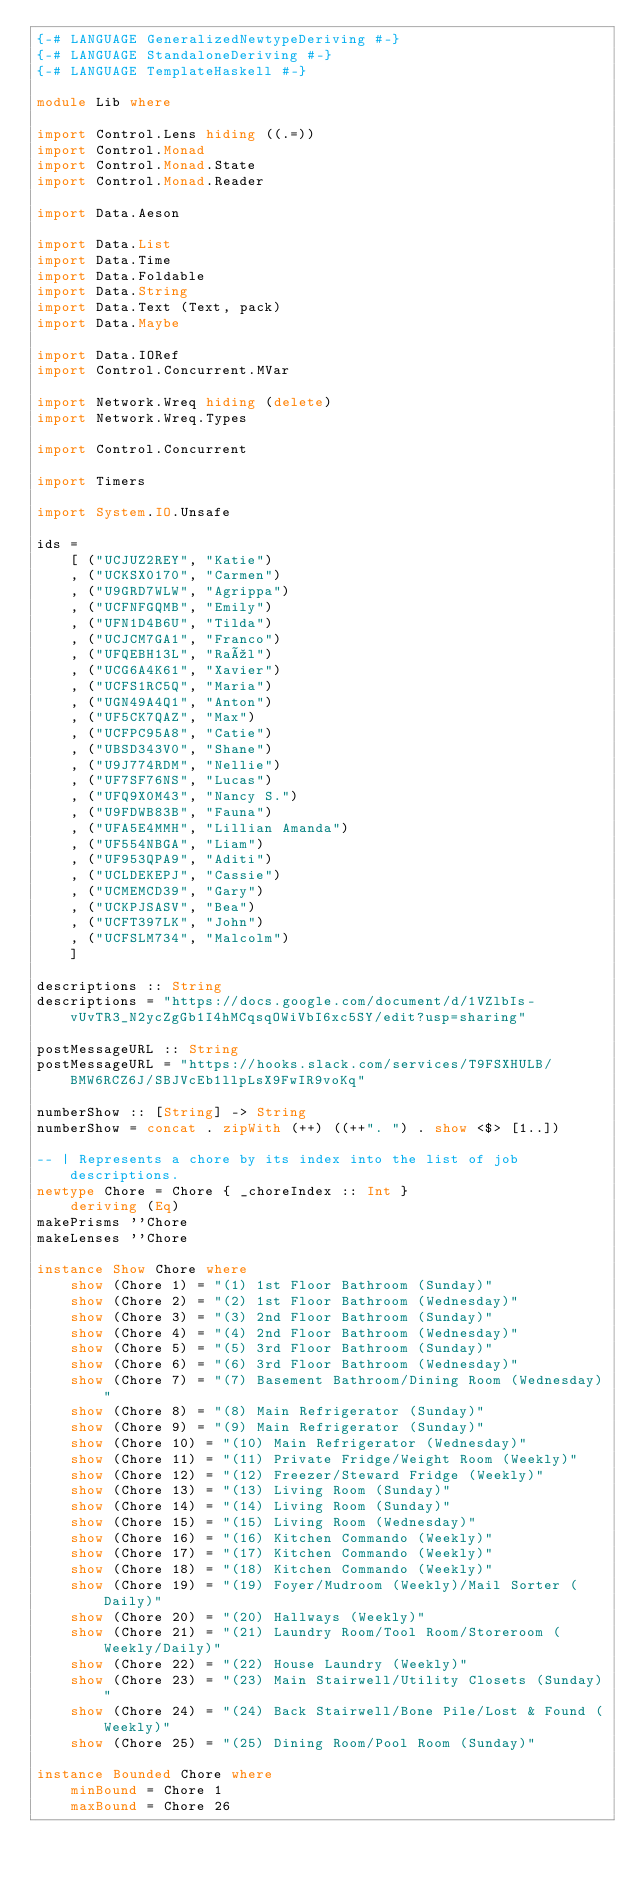<code> <loc_0><loc_0><loc_500><loc_500><_Haskell_>{-# LANGUAGE GeneralizedNewtypeDeriving #-}
{-# LANGUAGE StandaloneDeriving #-}
{-# LANGUAGE TemplateHaskell #-}

module Lib where

import Control.Lens hiding ((.=))
import Control.Monad
import Control.Monad.State
import Control.Monad.Reader

import Data.Aeson

import Data.List
import Data.Time
import Data.Foldable
import Data.String
import Data.Text (Text, pack)
import Data.Maybe

import Data.IORef
import Control.Concurrent.MVar

import Network.Wreq hiding (delete)
import Network.Wreq.Types

import Control.Concurrent

import Timers

import System.IO.Unsafe

ids =
    [ ("UCJUZ2REY", "Katie")
    , ("UCKSX0170", "Carmen")
    , ("U9GRD7WLW", "Agrippa")
    , ("UCFNFGQMB", "Emily")
    , ("UFN1D4B6U", "Tilda")
    , ("UCJCM7GA1", "Franco")
    , ("UFQEBH13L", "Raúl")
    , ("UCG6A4K61", "Xavier")
    , ("UCFS1RC5Q", "Maria")
    , ("UGN49A4Q1", "Anton")
    , ("UF5CK7QAZ", "Max")
    , ("UCFPC95A8", "Catie")
    , ("UBSD343V0", "Shane")
    , ("U9J774RDM", "Nellie")
    , ("UF7SF76NS", "Lucas")
    , ("UFQ9X0M43", "Nancy S.")
    , ("U9FDWB83B", "Fauna")
    , ("UFA5E4MMH", "Lillian Amanda")
    , ("UF554NBGA", "Liam")
    , ("UF953QPA9", "Aditi")
    , ("UCLDEKEPJ", "Cassie")
    , ("UCMEMCD39", "Gary")
    , ("UCKPJSASV", "Bea")
    , ("UCFT397LK", "John")
    , ("UCFSLM734", "Malcolm")
    ]

descriptions :: String
descriptions = "https://docs.google.com/document/d/1VZlbIs-vUvTR3_N2ycZgGb1I4hMCqsqOWiVbI6xc5SY/edit?usp=sharing"

postMessageURL :: String
postMessageURL = "https://hooks.slack.com/services/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"

numberShow :: [String] -> String
numberShow = concat . zipWith (++) ((++". ") . show <$> [1..])

-- | Represents a chore by its index into the list of job descriptions.
newtype Chore = Chore { _choreIndex :: Int }
    deriving (Eq)
makePrisms ''Chore
makeLenses ''Chore

instance Show Chore where
    show (Chore 1) = "(1) 1st Floor Bathroom (Sunday)"
    show (Chore 2) = "(2) 1st Floor Bathroom (Wednesday)"
    show (Chore 3) = "(3) 2nd Floor Bathroom (Sunday)"
    show (Chore 4) = "(4) 2nd Floor Bathroom (Wednesday)"
    show (Chore 5) = "(5) 3rd Floor Bathroom (Sunday)"
    show (Chore 6) = "(6) 3rd Floor Bathroom (Wednesday)"
    show (Chore 7) = "(7) Basement Bathroom/Dining Room (Wednesday)"
    show (Chore 8) = "(8) Main Refrigerator (Sunday)"
    show (Chore 9) = "(9) Main Refrigerator (Sunday)"
    show (Chore 10) = "(10) Main Refrigerator (Wednesday)"
    show (Chore 11) = "(11) Private Fridge/Weight Room (Weekly)"
    show (Chore 12) = "(12) Freezer/Steward Fridge (Weekly)"
    show (Chore 13) = "(13) Living Room (Sunday)"
    show (Chore 14) = "(14) Living Room (Sunday)"
    show (Chore 15) = "(15) Living Room (Wednesday)"
    show (Chore 16) = "(16) Kitchen Commando (Weekly)"
    show (Chore 17) = "(17) Kitchen Commando (Weekly)"
    show (Chore 18) = "(18) Kitchen Commando (Weekly)"
    show (Chore 19) = "(19) Foyer/Mudroom (Weekly)/Mail Sorter (Daily)"
    show (Chore 20) = "(20) Hallways (Weekly)"
    show (Chore 21) = "(21) Laundry Room/Tool Room/Storeroom (Weekly/Daily)"
    show (Chore 22) = "(22) House Laundry (Weekly)"
    show (Chore 23) = "(23) Main Stairwell/Utility Closets (Sunday)"
    show (Chore 24) = "(24) Back Stairwell/Bone Pile/Lost & Found (Weekly)"
    show (Chore 25) = "(25) Dining Room/Pool Room (Sunday)"

instance Bounded Chore where
    minBound = Chore 1
    maxBound = Chore 26
</code> 